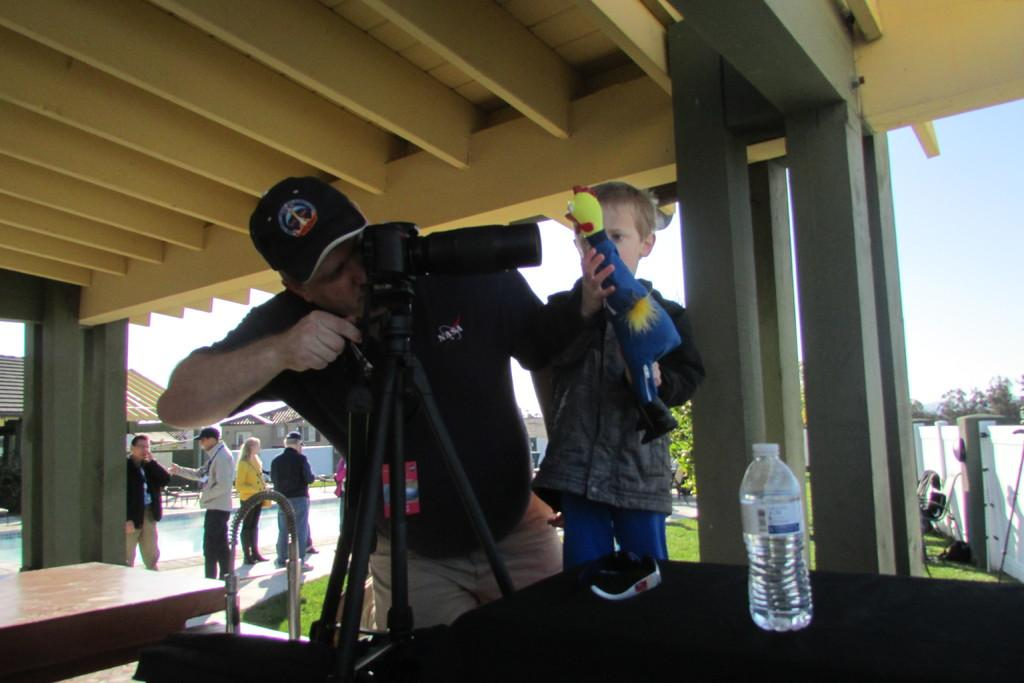Who is the main subject in the image? There is a man in the image. What is the man doing in the image? The man is operating a camera. Are there any other people in the image? Yes, there is a boy in the image. What is the boy holding in the image? The boy is holding a toy. What type of yard is visible in the image? There is no yard visible in the image. 